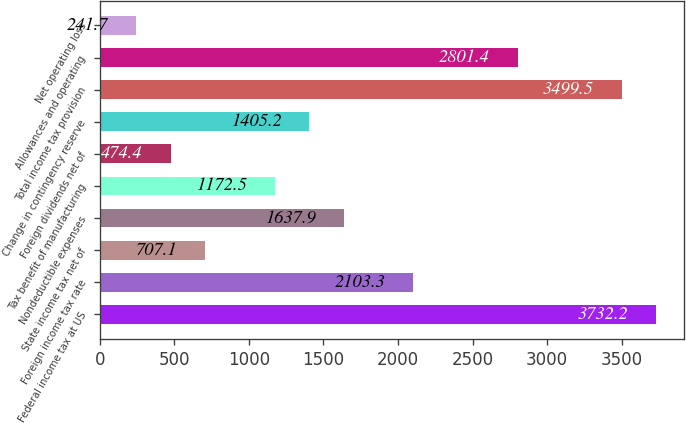Convert chart. <chart><loc_0><loc_0><loc_500><loc_500><bar_chart><fcel>Federal income tax at US<fcel>Foreign income tax rate<fcel>State income tax net of<fcel>Nondeductible expenses<fcel>Tax benefit of manufacturing<fcel>Foreign dividends net of<fcel>Change in contingency reserve<fcel>Total income tax provision<fcel>Allowances and operating<fcel>Net operating loss<nl><fcel>3732.2<fcel>2103.3<fcel>707.1<fcel>1637.9<fcel>1172.5<fcel>474.4<fcel>1405.2<fcel>3499.5<fcel>2801.4<fcel>241.7<nl></chart> 